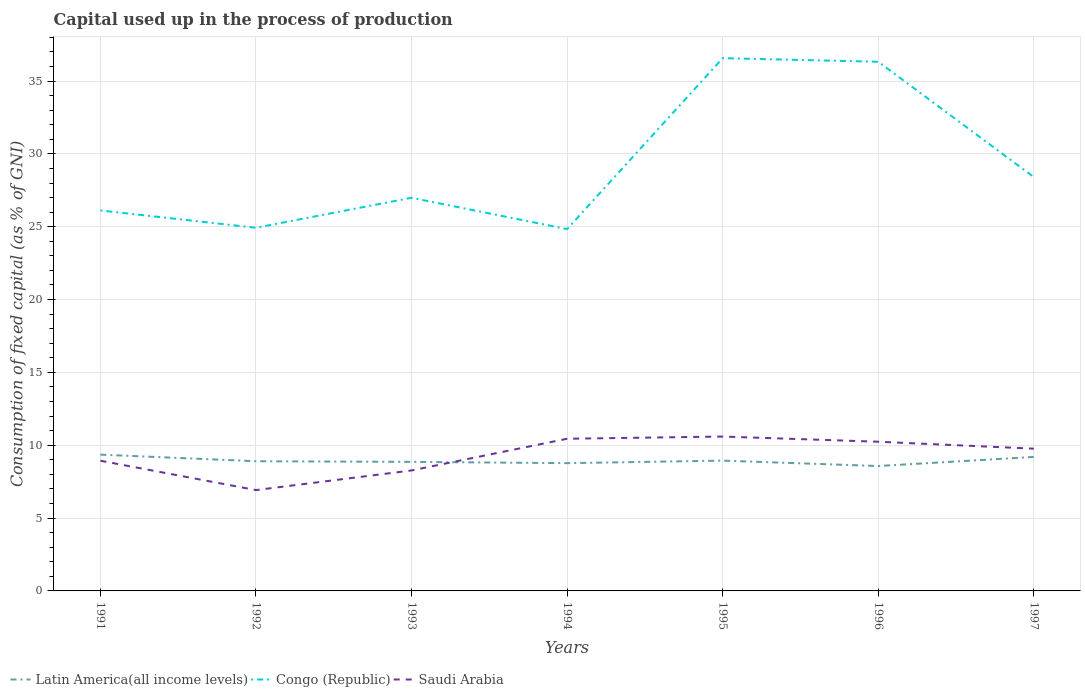Across all years, what is the maximum capital used up in the process of production in Saudi Arabia?
Your response must be concise. 6.92. In which year was the capital used up in the process of production in Congo (Republic) maximum?
Give a very brief answer. 1994. What is the total capital used up in the process of production in Congo (Republic) in the graph?
Your answer should be very brief. -10.45. What is the difference between the highest and the second highest capital used up in the process of production in Congo (Republic)?
Give a very brief answer. 11.73. What is the difference between the highest and the lowest capital used up in the process of production in Latin America(all income levels)?
Give a very brief answer. 3. Is the capital used up in the process of production in Congo (Republic) strictly greater than the capital used up in the process of production in Saudi Arabia over the years?
Keep it short and to the point. No. How many lines are there?
Provide a short and direct response. 3. How many years are there in the graph?
Provide a succinct answer. 7. Are the values on the major ticks of Y-axis written in scientific E-notation?
Provide a succinct answer. No. Does the graph contain grids?
Provide a succinct answer. Yes. Where does the legend appear in the graph?
Provide a succinct answer. Bottom left. How many legend labels are there?
Make the answer very short. 3. What is the title of the graph?
Your answer should be compact. Capital used up in the process of production. Does "Cyprus" appear as one of the legend labels in the graph?
Make the answer very short. No. What is the label or title of the X-axis?
Ensure brevity in your answer.  Years. What is the label or title of the Y-axis?
Offer a terse response. Consumption of fixed capital (as % of GNI). What is the Consumption of fixed capital (as % of GNI) in Latin America(all income levels) in 1991?
Provide a short and direct response. 9.36. What is the Consumption of fixed capital (as % of GNI) of Congo (Republic) in 1991?
Offer a terse response. 26.12. What is the Consumption of fixed capital (as % of GNI) of Saudi Arabia in 1991?
Your response must be concise. 8.94. What is the Consumption of fixed capital (as % of GNI) of Latin America(all income levels) in 1992?
Provide a succinct answer. 8.9. What is the Consumption of fixed capital (as % of GNI) in Congo (Republic) in 1992?
Keep it short and to the point. 24.93. What is the Consumption of fixed capital (as % of GNI) of Saudi Arabia in 1992?
Keep it short and to the point. 6.92. What is the Consumption of fixed capital (as % of GNI) of Latin America(all income levels) in 1993?
Provide a succinct answer. 8.86. What is the Consumption of fixed capital (as % of GNI) in Congo (Republic) in 1993?
Provide a short and direct response. 26.99. What is the Consumption of fixed capital (as % of GNI) of Saudi Arabia in 1993?
Provide a succinct answer. 8.27. What is the Consumption of fixed capital (as % of GNI) of Latin America(all income levels) in 1994?
Offer a terse response. 8.77. What is the Consumption of fixed capital (as % of GNI) of Congo (Republic) in 1994?
Provide a succinct answer. 24.84. What is the Consumption of fixed capital (as % of GNI) in Saudi Arabia in 1994?
Make the answer very short. 10.45. What is the Consumption of fixed capital (as % of GNI) in Latin America(all income levels) in 1995?
Keep it short and to the point. 8.94. What is the Consumption of fixed capital (as % of GNI) of Congo (Republic) in 1995?
Your answer should be very brief. 36.57. What is the Consumption of fixed capital (as % of GNI) in Saudi Arabia in 1995?
Make the answer very short. 10.6. What is the Consumption of fixed capital (as % of GNI) of Latin America(all income levels) in 1996?
Your answer should be compact. 8.57. What is the Consumption of fixed capital (as % of GNI) in Congo (Republic) in 1996?
Ensure brevity in your answer.  36.32. What is the Consumption of fixed capital (as % of GNI) of Saudi Arabia in 1996?
Provide a succinct answer. 10.24. What is the Consumption of fixed capital (as % of GNI) of Latin America(all income levels) in 1997?
Offer a very short reply. 9.2. What is the Consumption of fixed capital (as % of GNI) of Congo (Republic) in 1997?
Ensure brevity in your answer.  28.41. What is the Consumption of fixed capital (as % of GNI) in Saudi Arabia in 1997?
Provide a short and direct response. 9.76. Across all years, what is the maximum Consumption of fixed capital (as % of GNI) of Latin America(all income levels)?
Your answer should be very brief. 9.36. Across all years, what is the maximum Consumption of fixed capital (as % of GNI) in Congo (Republic)?
Give a very brief answer. 36.57. Across all years, what is the maximum Consumption of fixed capital (as % of GNI) in Saudi Arabia?
Provide a short and direct response. 10.6. Across all years, what is the minimum Consumption of fixed capital (as % of GNI) in Latin America(all income levels)?
Your answer should be very brief. 8.57. Across all years, what is the minimum Consumption of fixed capital (as % of GNI) in Congo (Republic)?
Offer a terse response. 24.84. Across all years, what is the minimum Consumption of fixed capital (as % of GNI) of Saudi Arabia?
Your answer should be very brief. 6.92. What is the total Consumption of fixed capital (as % of GNI) in Latin America(all income levels) in the graph?
Your answer should be very brief. 62.6. What is the total Consumption of fixed capital (as % of GNI) in Congo (Republic) in the graph?
Provide a succinct answer. 204.17. What is the total Consumption of fixed capital (as % of GNI) in Saudi Arabia in the graph?
Ensure brevity in your answer.  65.18. What is the difference between the Consumption of fixed capital (as % of GNI) in Latin America(all income levels) in 1991 and that in 1992?
Offer a terse response. 0.45. What is the difference between the Consumption of fixed capital (as % of GNI) of Congo (Republic) in 1991 and that in 1992?
Offer a terse response. 1.19. What is the difference between the Consumption of fixed capital (as % of GNI) of Saudi Arabia in 1991 and that in 1992?
Offer a very short reply. 2.01. What is the difference between the Consumption of fixed capital (as % of GNI) in Latin America(all income levels) in 1991 and that in 1993?
Offer a very short reply. 0.5. What is the difference between the Consumption of fixed capital (as % of GNI) in Congo (Republic) in 1991 and that in 1993?
Your response must be concise. -0.87. What is the difference between the Consumption of fixed capital (as % of GNI) in Saudi Arabia in 1991 and that in 1993?
Give a very brief answer. 0.67. What is the difference between the Consumption of fixed capital (as % of GNI) of Latin America(all income levels) in 1991 and that in 1994?
Provide a short and direct response. 0.58. What is the difference between the Consumption of fixed capital (as % of GNI) of Congo (Republic) in 1991 and that in 1994?
Provide a succinct answer. 1.28. What is the difference between the Consumption of fixed capital (as % of GNI) in Saudi Arabia in 1991 and that in 1994?
Provide a short and direct response. -1.51. What is the difference between the Consumption of fixed capital (as % of GNI) in Latin America(all income levels) in 1991 and that in 1995?
Keep it short and to the point. 0.41. What is the difference between the Consumption of fixed capital (as % of GNI) in Congo (Republic) in 1991 and that in 1995?
Keep it short and to the point. -10.45. What is the difference between the Consumption of fixed capital (as % of GNI) in Saudi Arabia in 1991 and that in 1995?
Your answer should be very brief. -1.66. What is the difference between the Consumption of fixed capital (as % of GNI) of Latin America(all income levels) in 1991 and that in 1996?
Ensure brevity in your answer.  0.78. What is the difference between the Consumption of fixed capital (as % of GNI) of Congo (Republic) in 1991 and that in 1996?
Your response must be concise. -10.2. What is the difference between the Consumption of fixed capital (as % of GNI) in Saudi Arabia in 1991 and that in 1996?
Provide a succinct answer. -1.31. What is the difference between the Consumption of fixed capital (as % of GNI) in Latin America(all income levels) in 1991 and that in 1997?
Ensure brevity in your answer.  0.16. What is the difference between the Consumption of fixed capital (as % of GNI) in Congo (Republic) in 1991 and that in 1997?
Offer a very short reply. -2.29. What is the difference between the Consumption of fixed capital (as % of GNI) in Saudi Arabia in 1991 and that in 1997?
Provide a short and direct response. -0.83. What is the difference between the Consumption of fixed capital (as % of GNI) of Latin America(all income levels) in 1992 and that in 1993?
Offer a terse response. 0.04. What is the difference between the Consumption of fixed capital (as % of GNI) of Congo (Republic) in 1992 and that in 1993?
Your response must be concise. -2.06. What is the difference between the Consumption of fixed capital (as % of GNI) in Saudi Arabia in 1992 and that in 1993?
Offer a very short reply. -1.35. What is the difference between the Consumption of fixed capital (as % of GNI) of Latin America(all income levels) in 1992 and that in 1994?
Provide a succinct answer. 0.13. What is the difference between the Consumption of fixed capital (as % of GNI) in Congo (Republic) in 1992 and that in 1994?
Your answer should be very brief. 0.09. What is the difference between the Consumption of fixed capital (as % of GNI) of Saudi Arabia in 1992 and that in 1994?
Keep it short and to the point. -3.52. What is the difference between the Consumption of fixed capital (as % of GNI) of Latin America(all income levels) in 1992 and that in 1995?
Your answer should be compact. -0.04. What is the difference between the Consumption of fixed capital (as % of GNI) of Congo (Republic) in 1992 and that in 1995?
Keep it short and to the point. -11.64. What is the difference between the Consumption of fixed capital (as % of GNI) in Saudi Arabia in 1992 and that in 1995?
Provide a short and direct response. -3.67. What is the difference between the Consumption of fixed capital (as % of GNI) in Latin America(all income levels) in 1992 and that in 1996?
Give a very brief answer. 0.33. What is the difference between the Consumption of fixed capital (as % of GNI) in Congo (Republic) in 1992 and that in 1996?
Give a very brief answer. -11.39. What is the difference between the Consumption of fixed capital (as % of GNI) of Saudi Arabia in 1992 and that in 1996?
Your answer should be compact. -3.32. What is the difference between the Consumption of fixed capital (as % of GNI) of Latin America(all income levels) in 1992 and that in 1997?
Give a very brief answer. -0.3. What is the difference between the Consumption of fixed capital (as % of GNI) in Congo (Republic) in 1992 and that in 1997?
Make the answer very short. -3.48. What is the difference between the Consumption of fixed capital (as % of GNI) in Saudi Arabia in 1992 and that in 1997?
Offer a terse response. -2.84. What is the difference between the Consumption of fixed capital (as % of GNI) of Latin America(all income levels) in 1993 and that in 1994?
Your answer should be compact. 0.09. What is the difference between the Consumption of fixed capital (as % of GNI) of Congo (Republic) in 1993 and that in 1994?
Offer a very short reply. 2.15. What is the difference between the Consumption of fixed capital (as % of GNI) in Saudi Arabia in 1993 and that in 1994?
Give a very brief answer. -2.18. What is the difference between the Consumption of fixed capital (as % of GNI) in Latin America(all income levels) in 1993 and that in 1995?
Offer a very short reply. -0.09. What is the difference between the Consumption of fixed capital (as % of GNI) of Congo (Republic) in 1993 and that in 1995?
Ensure brevity in your answer.  -9.58. What is the difference between the Consumption of fixed capital (as % of GNI) in Saudi Arabia in 1993 and that in 1995?
Your answer should be very brief. -2.33. What is the difference between the Consumption of fixed capital (as % of GNI) of Latin America(all income levels) in 1993 and that in 1996?
Make the answer very short. 0.29. What is the difference between the Consumption of fixed capital (as % of GNI) in Congo (Republic) in 1993 and that in 1996?
Offer a terse response. -9.34. What is the difference between the Consumption of fixed capital (as % of GNI) in Saudi Arabia in 1993 and that in 1996?
Offer a terse response. -1.97. What is the difference between the Consumption of fixed capital (as % of GNI) of Latin America(all income levels) in 1993 and that in 1997?
Keep it short and to the point. -0.34. What is the difference between the Consumption of fixed capital (as % of GNI) of Congo (Republic) in 1993 and that in 1997?
Give a very brief answer. -1.42. What is the difference between the Consumption of fixed capital (as % of GNI) in Saudi Arabia in 1993 and that in 1997?
Provide a short and direct response. -1.5. What is the difference between the Consumption of fixed capital (as % of GNI) in Latin America(all income levels) in 1994 and that in 1995?
Provide a short and direct response. -0.17. What is the difference between the Consumption of fixed capital (as % of GNI) in Congo (Republic) in 1994 and that in 1995?
Make the answer very short. -11.73. What is the difference between the Consumption of fixed capital (as % of GNI) in Saudi Arabia in 1994 and that in 1995?
Provide a short and direct response. -0.15. What is the difference between the Consumption of fixed capital (as % of GNI) of Latin America(all income levels) in 1994 and that in 1996?
Your answer should be very brief. 0.2. What is the difference between the Consumption of fixed capital (as % of GNI) of Congo (Republic) in 1994 and that in 1996?
Keep it short and to the point. -11.49. What is the difference between the Consumption of fixed capital (as % of GNI) of Saudi Arabia in 1994 and that in 1996?
Keep it short and to the point. 0.2. What is the difference between the Consumption of fixed capital (as % of GNI) of Latin America(all income levels) in 1994 and that in 1997?
Provide a succinct answer. -0.43. What is the difference between the Consumption of fixed capital (as % of GNI) in Congo (Republic) in 1994 and that in 1997?
Provide a succinct answer. -3.57. What is the difference between the Consumption of fixed capital (as % of GNI) of Saudi Arabia in 1994 and that in 1997?
Your answer should be very brief. 0.68. What is the difference between the Consumption of fixed capital (as % of GNI) of Latin America(all income levels) in 1995 and that in 1996?
Provide a short and direct response. 0.37. What is the difference between the Consumption of fixed capital (as % of GNI) of Congo (Republic) in 1995 and that in 1996?
Keep it short and to the point. 0.25. What is the difference between the Consumption of fixed capital (as % of GNI) of Saudi Arabia in 1995 and that in 1996?
Give a very brief answer. 0.36. What is the difference between the Consumption of fixed capital (as % of GNI) of Latin America(all income levels) in 1995 and that in 1997?
Make the answer very short. -0.25. What is the difference between the Consumption of fixed capital (as % of GNI) in Congo (Republic) in 1995 and that in 1997?
Your response must be concise. 8.16. What is the difference between the Consumption of fixed capital (as % of GNI) of Saudi Arabia in 1995 and that in 1997?
Make the answer very short. 0.83. What is the difference between the Consumption of fixed capital (as % of GNI) in Latin America(all income levels) in 1996 and that in 1997?
Provide a succinct answer. -0.63. What is the difference between the Consumption of fixed capital (as % of GNI) in Congo (Republic) in 1996 and that in 1997?
Provide a succinct answer. 7.91. What is the difference between the Consumption of fixed capital (as % of GNI) in Saudi Arabia in 1996 and that in 1997?
Keep it short and to the point. 0.48. What is the difference between the Consumption of fixed capital (as % of GNI) of Latin America(all income levels) in 1991 and the Consumption of fixed capital (as % of GNI) of Congo (Republic) in 1992?
Provide a short and direct response. -15.57. What is the difference between the Consumption of fixed capital (as % of GNI) in Latin America(all income levels) in 1991 and the Consumption of fixed capital (as % of GNI) in Saudi Arabia in 1992?
Make the answer very short. 2.43. What is the difference between the Consumption of fixed capital (as % of GNI) in Congo (Republic) in 1991 and the Consumption of fixed capital (as % of GNI) in Saudi Arabia in 1992?
Make the answer very short. 19.2. What is the difference between the Consumption of fixed capital (as % of GNI) of Latin America(all income levels) in 1991 and the Consumption of fixed capital (as % of GNI) of Congo (Republic) in 1993?
Make the answer very short. -17.63. What is the difference between the Consumption of fixed capital (as % of GNI) of Latin America(all income levels) in 1991 and the Consumption of fixed capital (as % of GNI) of Saudi Arabia in 1993?
Your answer should be very brief. 1.09. What is the difference between the Consumption of fixed capital (as % of GNI) of Congo (Republic) in 1991 and the Consumption of fixed capital (as % of GNI) of Saudi Arabia in 1993?
Offer a very short reply. 17.85. What is the difference between the Consumption of fixed capital (as % of GNI) in Latin America(all income levels) in 1991 and the Consumption of fixed capital (as % of GNI) in Congo (Republic) in 1994?
Keep it short and to the point. -15.48. What is the difference between the Consumption of fixed capital (as % of GNI) in Latin America(all income levels) in 1991 and the Consumption of fixed capital (as % of GNI) in Saudi Arabia in 1994?
Your answer should be compact. -1.09. What is the difference between the Consumption of fixed capital (as % of GNI) in Congo (Republic) in 1991 and the Consumption of fixed capital (as % of GNI) in Saudi Arabia in 1994?
Your response must be concise. 15.67. What is the difference between the Consumption of fixed capital (as % of GNI) of Latin America(all income levels) in 1991 and the Consumption of fixed capital (as % of GNI) of Congo (Republic) in 1995?
Provide a succinct answer. -27.21. What is the difference between the Consumption of fixed capital (as % of GNI) of Latin America(all income levels) in 1991 and the Consumption of fixed capital (as % of GNI) of Saudi Arabia in 1995?
Keep it short and to the point. -1.24. What is the difference between the Consumption of fixed capital (as % of GNI) of Congo (Republic) in 1991 and the Consumption of fixed capital (as % of GNI) of Saudi Arabia in 1995?
Offer a terse response. 15.52. What is the difference between the Consumption of fixed capital (as % of GNI) of Latin America(all income levels) in 1991 and the Consumption of fixed capital (as % of GNI) of Congo (Republic) in 1996?
Your answer should be very brief. -26.97. What is the difference between the Consumption of fixed capital (as % of GNI) in Latin America(all income levels) in 1991 and the Consumption of fixed capital (as % of GNI) in Saudi Arabia in 1996?
Keep it short and to the point. -0.89. What is the difference between the Consumption of fixed capital (as % of GNI) in Congo (Republic) in 1991 and the Consumption of fixed capital (as % of GNI) in Saudi Arabia in 1996?
Your answer should be very brief. 15.88. What is the difference between the Consumption of fixed capital (as % of GNI) of Latin America(all income levels) in 1991 and the Consumption of fixed capital (as % of GNI) of Congo (Republic) in 1997?
Your answer should be very brief. -19.05. What is the difference between the Consumption of fixed capital (as % of GNI) in Latin America(all income levels) in 1991 and the Consumption of fixed capital (as % of GNI) in Saudi Arabia in 1997?
Your response must be concise. -0.41. What is the difference between the Consumption of fixed capital (as % of GNI) of Congo (Republic) in 1991 and the Consumption of fixed capital (as % of GNI) of Saudi Arabia in 1997?
Give a very brief answer. 16.35. What is the difference between the Consumption of fixed capital (as % of GNI) in Latin America(all income levels) in 1992 and the Consumption of fixed capital (as % of GNI) in Congo (Republic) in 1993?
Your answer should be compact. -18.08. What is the difference between the Consumption of fixed capital (as % of GNI) in Latin America(all income levels) in 1992 and the Consumption of fixed capital (as % of GNI) in Saudi Arabia in 1993?
Provide a short and direct response. 0.63. What is the difference between the Consumption of fixed capital (as % of GNI) of Congo (Republic) in 1992 and the Consumption of fixed capital (as % of GNI) of Saudi Arabia in 1993?
Your answer should be compact. 16.66. What is the difference between the Consumption of fixed capital (as % of GNI) in Latin America(all income levels) in 1992 and the Consumption of fixed capital (as % of GNI) in Congo (Republic) in 1994?
Your response must be concise. -15.94. What is the difference between the Consumption of fixed capital (as % of GNI) of Latin America(all income levels) in 1992 and the Consumption of fixed capital (as % of GNI) of Saudi Arabia in 1994?
Your answer should be very brief. -1.54. What is the difference between the Consumption of fixed capital (as % of GNI) of Congo (Republic) in 1992 and the Consumption of fixed capital (as % of GNI) of Saudi Arabia in 1994?
Your answer should be very brief. 14.48. What is the difference between the Consumption of fixed capital (as % of GNI) in Latin America(all income levels) in 1992 and the Consumption of fixed capital (as % of GNI) in Congo (Republic) in 1995?
Your answer should be compact. -27.67. What is the difference between the Consumption of fixed capital (as % of GNI) in Latin America(all income levels) in 1992 and the Consumption of fixed capital (as % of GNI) in Saudi Arabia in 1995?
Make the answer very short. -1.7. What is the difference between the Consumption of fixed capital (as % of GNI) of Congo (Republic) in 1992 and the Consumption of fixed capital (as % of GNI) of Saudi Arabia in 1995?
Offer a very short reply. 14.33. What is the difference between the Consumption of fixed capital (as % of GNI) of Latin America(all income levels) in 1992 and the Consumption of fixed capital (as % of GNI) of Congo (Republic) in 1996?
Offer a very short reply. -27.42. What is the difference between the Consumption of fixed capital (as % of GNI) in Latin America(all income levels) in 1992 and the Consumption of fixed capital (as % of GNI) in Saudi Arabia in 1996?
Provide a short and direct response. -1.34. What is the difference between the Consumption of fixed capital (as % of GNI) in Congo (Republic) in 1992 and the Consumption of fixed capital (as % of GNI) in Saudi Arabia in 1996?
Give a very brief answer. 14.69. What is the difference between the Consumption of fixed capital (as % of GNI) of Latin America(all income levels) in 1992 and the Consumption of fixed capital (as % of GNI) of Congo (Republic) in 1997?
Ensure brevity in your answer.  -19.51. What is the difference between the Consumption of fixed capital (as % of GNI) in Latin America(all income levels) in 1992 and the Consumption of fixed capital (as % of GNI) in Saudi Arabia in 1997?
Offer a terse response. -0.86. What is the difference between the Consumption of fixed capital (as % of GNI) in Congo (Republic) in 1992 and the Consumption of fixed capital (as % of GNI) in Saudi Arabia in 1997?
Offer a terse response. 15.16. What is the difference between the Consumption of fixed capital (as % of GNI) of Latin America(all income levels) in 1993 and the Consumption of fixed capital (as % of GNI) of Congo (Republic) in 1994?
Ensure brevity in your answer.  -15.98. What is the difference between the Consumption of fixed capital (as % of GNI) of Latin America(all income levels) in 1993 and the Consumption of fixed capital (as % of GNI) of Saudi Arabia in 1994?
Provide a short and direct response. -1.59. What is the difference between the Consumption of fixed capital (as % of GNI) in Congo (Republic) in 1993 and the Consumption of fixed capital (as % of GNI) in Saudi Arabia in 1994?
Make the answer very short. 16.54. What is the difference between the Consumption of fixed capital (as % of GNI) of Latin America(all income levels) in 1993 and the Consumption of fixed capital (as % of GNI) of Congo (Republic) in 1995?
Your answer should be compact. -27.71. What is the difference between the Consumption of fixed capital (as % of GNI) of Latin America(all income levels) in 1993 and the Consumption of fixed capital (as % of GNI) of Saudi Arabia in 1995?
Keep it short and to the point. -1.74. What is the difference between the Consumption of fixed capital (as % of GNI) in Congo (Republic) in 1993 and the Consumption of fixed capital (as % of GNI) in Saudi Arabia in 1995?
Give a very brief answer. 16.39. What is the difference between the Consumption of fixed capital (as % of GNI) in Latin America(all income levels) in 1993 and the Consumption of fixed capital (as % of GNI) in Congo (Republic) in 1996?
Offer a very short reply. -27.46. What is the difference between the Consumption of fixed capital (as % of GNI) of Latin America(all income levels) in 1993 and the Consumption of fixed capital (as % of GNI) of Saudi Arabia in 1996?
Keep it short and to the point. -1.38. What is the difference between the Consumption of fixed capital (as % of GNI) in Congo (Republic) in 1993 and the Consumption of fixed capital (as % of GNI) in Saudi Arabia in 1996?
Offer a very short reply. 16.74. What is the difference between the Consumption of fixed capital (as % of GNI) in Latin America(all income levels) in 1993 and the Consumption of fixed capital (as % of GNI) in Congo (Republic) in 1997?
Offer a terse response. -19.55. What is the difference between the Consumption of fixed capital (as % of GNI) in Latin America(all income levels) in 1993 and the Consumption of fixed capital (as % of GNI) in Saudi Arabia in 1997?
Provide a short and direct response. -0.91. What is the difference between the Consumption of fixed capital (as % of GNI) of Congo (Republic) in 1993 and the Consumption of fixed capital (as % of GNI) of Saudi Arabia in 1997?
Offer a terse response. 17.22. What is the difference between the Consumption of fixed capital (as % of GNI) of Latin America(all income levels) in 1994 and the Consumption of fixed capital (as % of GNI) of Congo (Republic) in 1995?
Offer a terse response. -27.8. What is the difference between the Consumption of fixed capital (as % of GNI) in Latin America(all income levels) in 1994 and the Consumption of fixed capital (as % of GNI) in Saudi Arabia in 1995?
Your response must be concise. -1.83. What is the difference between the Consumption of fixed capital (as % of GNI) in Congo (Republic) in 1994 and the Consumption of fixed capital (as % of GNI) in Saudi Arabia in 1995?
Offer a very short reply. 14.24. What is the difference between the Consumption of fixed capital (as % of GNI) of Latin America(all income levels) in 1994 and the Consumption of fixed capital (as % of GNI) of Congo (Republic) in 1996?
Keep it short and to the point. -27.55. What is the difference between the Consumption of fixed capital (as % of GNI) in Latin America(all income levels) in 1994 and the Consumption of fixed capital (as % of GNI) in Saudi Arabia in 1996?
Give a very brief answer. -1.47. What is the difference between the Consumption of fixed capital (as % of GNI) of Congo (Republic) in 1994 and the Consumption of fixed capital (as % of GNI) of Saudi Arabia in 1996?
Ensure brevity in your answer.  14.6. What is the difference between the Consumption of fixed capital (as % of GNI) of Latin America(all income levels) in 1994 and the Consumption of fixed capital (as % of GNI) of Congo (Republic) in 1997?
Make the answer very short. -19.64. What is the difference between the Consumption of fixed capital (as % of GNI) in Latin America(all income levels) in 1994 and the Consumption of fixed capital (as % of GNI) in Saudi Arabia in 1997?
Provide a succinct answer. -0.99. What is the difference between the Consumption of fixed capital (as % of GNI) in Congo (Republic) in 1994 and the Consumption of fixed capital (as % of GNI) in Saudi Arabia in 1997?
Provide a short and direct response. 15.07. What is the difference between the Consumption of fixed capital (as % of GNI) in Latin America(all income levels) in 1995 and the Consumption of fixed capital (as % of GNI) in Congo (Republic) in 1996?
Your answer should be compact. -27.38. What is the difference between the Consumption of fixed capital (as % of GNI) in Latin America(all income levels) in 1995 and the Consumption of fixed capital (as % of GNI) in Saudi Arabia in 1996?
Your answer should be compact. -1.3. What is the difference between the Consumption of fixed capital (as % of GNI) in Congo (Republic) in 1995 and the Consumption of fixed capital (as % of GNI) in Saudi Arabia in 1996?
Make the answer very short. 26.33. What is the difference between the Consumption of fixed capital (as % of GNI) of Latin America(all income levels) in 1995 and the Consumption of fixed capital (as % of GNI) of Congo (Republic) in 1997?
Make the answer very short. -19.46. What is the difference between the Consumption of fixed capital (as % of GNI) of Latin America(all income levels) in 1995 and the Consumption of fixed capital (as % of GNI) of Saudi Arabia in 1997?
Make the answer very short. -0.82. What is the difference between the Consumption of fixed capital (as % of GNI) of Congo (Republic) in 1995 and the Consumption of fixed capital (as % of GNI) of Saudi Arabia in 1997?
Offer a terse response. 26.8. What is the difference between the Consumption of fixed capital (as % of GNI) of Latin America(all income levels) in 1996 and the Consumption of fixed capital (as % of GNI) of Congo (Republic) in 1997?
Provide a succinct answer. -19.84. What is the difference between the Consumption of fixed capital (as % of GNI) of Latin America(all income levels) in 1996 and the Consumption of fixed capital (as % of GNI) of Saudi Arabia in 1997?
Your response must be concise. -1.19. What is the difference between the Consumption of fixed capital (as % of GNI) in Congo (Republic) in 1996 and the Consumption of fixed capital (as % of GNI) in Saudi Arabia in 1997?
Give a very brief answer. 26.56. What is the average Consumption of fixed capital (as % of GNI) in Latin America(all income levels) per year?
Provide a succinct answer. 8.94. What is the average Consumption of fixed capital (as % of GNI) in Congo (Republic) per year?
Offer a very short reply. 29.17. What is the average Consumption of fixed capital (as % of GNI) of Saudi Arabia per year?
Offer a very short reply. 9.31. In the year 1991, what is the difference between the Consumption of fixed capital (as % of GNI) of Latin America(all income levels) and Consumption of fixed capital (as % of GNI) of Congo (Republic)?
Offer a very short reply. -16.76. In the year 1991, what is the difference between the Consumption of fixed capital (as % of GNI) of Latin America(all income levels) and Consumption of fixed capital (as % of GNI) of Saudi Arabia?
Make the answer very short. 0.42. In the year 1991, what is the difference between the Consumption of fixed capital (as % of GNI) of Congo (Republic) and Consumption of fixed capital (as % of GNI) of Saudi Arabia?
Your response must be concise. 17.18. In the year 1992, what is the difference between the Consumption of fixed capital (as % of GNI) in Latin America(all income levels) and Consumption of fixed capital (as % of GNI) in Congo (Republic)?
Make the answer very short. -16.03. In the year 1992, what is the difference between the Consumption of fixed capital (as % of GNI) in Latin America(all income levels) and Consumption of fixed capital (as % of GNI) in Saudi Arabia?
Provide a short and direct response. 1.98. In the year 1992, what is the difference between the Consumption of fixed capital (as % of GNI) of Congo (Republic) and Consumption of fixed capital (as % of GNI) of Saudi Arabia?
Keep it short and to the point. 18.01. In the year 1993, what is the difference between the Consumption of fixed capital (as % of GNI) in Latin America(all income levels) and Consumption of fixed capital (as % of GNI) in Congo (Republic)?
Your answer should be compact. -18.13. In the year 1993, what is the difference between the Consumption of fixed capital (as % of GNI) of Latin America(all income levels) and Consumption of fixed capital (as % of GNI) of Saudi Arabia?
Offer a very short reply. 0.59. In the year 1993, what is the difference between the Consumption of fixed capital (as % of GNI) of Congo (Republic) and Consumption of fixed capital (as % of GNI) of Saudi Arabia?
Your answer should be compact. 18.72. In the year 1994, what is the difference between the Consumption of fixed capital (as % of GNI) in Latin America(all income levels) and Consumption of fixed capital (as % of GNI) in Congo (Republic)?
Offer a very short reply. -16.07. In the year 1994, what is the difference between the Consumption of fixed capital (as % of GNI) of Latin America(all income levels) and Consumption of fixed capital (as % of GNI) of Saudi Arabia?
Ensure brevity in your answer.  -1.68. In the year 1994, what is the difference between the Consumption of fixed capital (as % of GNI) in Congo (Republic) and Consumption of fixed capital (as % of GNI) in Saudi Arabia?
Offer a terse response. 14.39. In the year 1995, what is the difference between the Consumption of fixed capital (as % of GNI) in Latin America(all income levels) and Consumption of fixed capital (as % of GNI) in Congo (Republic)?
Your response must be concise. -27.63. In the year 1995, what is the difference between the Consumption of fixed capital (as % of GNI) of Latin America(all income levels) and Consumption of fixed capital (as % of GNI) of Saudi Arabia?
Provide a succinct answer. -1.65. In the year 1995, what is the difference between the Consumption of fixed capital (as % of GNI) of Congo (Republic) and Consumption of fixed capital (as % of GNI) of Saudi Arabia?
Your response must be concise. 25.97. In the year 1996, what is the difference between the Consumption of fixed capital (as % of GNI) of Latin America(all income levels) and Consumption of fixed capital (as % of GNI) of Congo (Republic)?
Offer a terse response. -27.75. In the year 1996, what is the difference between the Consumption of fixed capital (as % of GNI) in Latin America(all income levels) and Consumption of fixed capital (as % of GNI) in Saudi Arabia?
Make the answer very short. -1.67. In the year 1996, what is the difference between the Consumption of fixed capital (as % of GNI) in Congo (Republic) and Consumption of fixed capital (as % of GNI) in Saudi Arabia?
Your answer should be very brief. 26.08. In the year 1997, what is the difference between the Consumption of fixed capital (as % of GNI) of Latin America(all income levels) and Consumption of fixed capital (as % of GNI) of Congo (Republic)?
Offer a terse response. -19.21. In the year 1997, what is the difference between the Consumption of fixed capital (as % of GNI) of Latin America(all income levels) and Consumption of fixed capital (as % of GNI) of Saudi Arabia?
Ensure brevity in your answer.  -0.57. In the year 1997, what is the difference between the Consumption of fixed capital (as % of GNI) in Congo (Republic) and Consumption of fixed capital (as % of GNI) in Saudi Arabia?
Ensure brevity in your answer.  18.64. What is the ratio of the Consumption of fixed capital (as % of GNI) in Latin America(all income levels) in 1991 to that in 1992?
Offer a very short reply. 1.05. What is the ratio of the Consumption of fixed capital (as % of GNI) of Congo (Republic) in 1991 to that in 1992?
Offer a very short reply. 1.05. What is the ratio of the Consumption of fixed capital (as % of GNI) in Saudi Arabia in 1991 to that in 1992?
Keep it short and to the point. 1.29. What is the ratio of the Consumption of fixed capital (as % of GNI) of Latin America(all income levels) in 1991 to that in 1993?
Provide a succinct answer. 1.06. What is the ratio of the Consumption of fixed capital (as % of GNI) in Congo (Republic) in 1991 to that in 1993?
Offer a very short reply. 0.97. What is the ratio of the Consumption of fixed capital (as % of GNI) of Saudi Arabia in 1991 to that in 1993?
Your answer should be very brief. 1.08. What is the ratio of the Consumption of fixed capital (as % of GNI) in Latin America(all income levels) in 1991 to that in 1994?
Give a very brief answer. 1.07. What is the ratio of the Consumption of fixed capital (as % of GNI) in Congo (Republic) in 1991 to that in 1994?
Provide a short and direct response. 1.05. What is the ratio of the Consumption of fixed capital (as % of GNI) of Saudi Arabia in 1991 to that in 1994?
Make the answer very short. 0.86. What is the ratio of the Consumption of fixed capital (as % of GNI) of Latin America(all income levels) in 1991 to that in 1995?
Offer a terse response. 1.05. What is the ratio of the Consumption of fixed capital (as % of GNI) of Congo (Republic) in 1991 to that in 1995?
Keep it short and to the point. 0.71. What is the ratio of the Consumption of fixed capital (as % of GNI) of Saudi Arabia in 1991 to that in 1995?
Make the answer very short. 0.84. What is the ratio of the Consumption of fixed capital (as % of GNI) of Latin America(all income levels) in 1991 to that in 1996?
Offer a very short reply. 1.09. What is the ratio of the Consumption of fixed capital (as % of GNI) in Congo (Republic) in 1991 to that in 1996?
Give a very brief answer. 0.72. What is the ratio of the Consumption of fixed capital (as % of GNI) of Saudi Arabia in 1991 to that in 1996?
Provide a short and direct response. 0.87. What is the ratio of the Consumption of fixed capital (as % of GNI) of Latin America(all income levels) in 1991 to that in 1997?
Offer a very short reply. 1.02. What is the ratio of the Consumption of fixed capital (as % of GNI) in Congo (Republic) in 1991 to that in 1997?
Your answer should be compact. 0.92. What is the ratio of the Consumption of fixed capital (as % of GNI) in Saudi Arabia in 1991 to that in 1997?
Give a very brief answer. 0.92. What is the ratio of the Consumption of fixed capital (as % of GNI) of Latin America(all income levels) in 1992 to that in 1993?
Ensure brevity in your answer.  1. What is the ratio of the Consumption of fixed capital (as % of GNI) in Congo (Republic) in 1992 to that in 1993?
Your answer should be compact. 0.92. What is the ratio of the Consumption of fixed capital (as % of GNI) in Saudi Arabia in 1992 to that in 1993?
Make the answer very short. 0.84. What is the ratio of the Consumption of fixed capital (as % of GNI) of Latin America(all income levels) in 1992 to that in 1994?
Your answer should be very brief. 1.01. What is the ratio of the Consumption of fixed capital (as % of GNI) of Saudi Arabia in 1992 to that in 1994?
Ensure brevity in your answer.  0.66. What is the ratio of the Consumption of fixed capital (as % of GNI) of Congo (Republic) in 1992 to that in 1995?
Give a very brief answer. 0.68. What is the ratio of the Consumption of fixed capital (as % of GNI) of Saudi Arabia in 1992 to that in 1995?
Provide a succinct answer. 0.65. What is the ratio of the Consumption of fixed capital (as % of GNI) of Latin America(all income levels) in 1992 to that in 1996?
Your answer should be very brief. 1.04. What is the ratio of the Consumption of fixed capital (as % of GNI) in Congo (Republic) in 1992 to that in 1996?
Offer a terse response. 0.69. What is the ratio of the Consumption of fixed capital (as % of GNI) of Saudi Arabia in 1992 to that in 1996?
Ensure brevity in your answer.  0.68. What is the ratio of the Consumption of fixed capital (as % of GNI) of Latin America(all income levels) in 1992 to that in 1997?
Provide a short and direct response. 0.97. What is the ratio of the Consumption of fixed capital (as % of GNI) in Congo (Republic) in 1992 to that in 1997?
Give a very brief answer. 0.88. What is the ratio of the Consumption of fixed capital (as % of GNI) of Saudi Arabia in 1992 to that in 1997?
Keep it short and to the point. 0.71. What is the ratio of the Consumption of fixed capital (as % of GNI) in Latin America(all income levels) in 1993 to that in 1994?
Keep it short and to the point. 1.01. What is the ratio of the Consumption of fixed capital (as % of GNI) in Congo (Republic) in 1993 to that in 1994?
Provide a short and direct response. 1.09. What is the ratio of the Consumption of fixed capital (as % of GNI) in Saudi Arabia in 1993 to that in 1994?
Your answer should be very brief. 0.79. What is the ratio of the Consumption of fixed capital (as % of GNI) of Latin America(all income levels) in 1993 to that in 1995?
Offer a very short reply. 0.99. What is the ratio of the Consumption of fixed capital (as % of GNI) in Congo (Republic) in 1993 to that in 1995?
Make the answer very short. 0.74. What is the ratio of the Consumption of fixed capital (as % of GNI) in Saudi Arabia in 1993 to that in 1995?
Offer a very short reply. 0.78. What is the ratio of the Consumption of fixed capital (as % of GNI) of Congo (Republic) in 1993 to that in 1996?
Offer a very short reply. 0.74. What is the ratio of the Consumption of fixed capital (as % of GNI) in Saudi Arabia in 1993 to that in 1996?
Give a very brief answer. 0.81. What is the ratio of the Consumption of fixed capital (as % of GNI) of Latin America(all income levels) in 1993 to that in 1997?
Ensure brevity in your answer.  0.96. What is the ratio of the Consumption of fixed capital (as % of GNI) of Congo (Republic) in 1993 to that in 1997?
Make the answer very short. 0.95. What is the ratio of the Consumption of fixed capital (as % of GNI) of Saudi Arabia in 1993 to that in 1997?
Give a very brief answer. 0.85. What is the ratio of the Consumption of fixed capital (as % of GNI) in Latin America(all income levels) in 1994 to that in 1995?
Offer a very short reply. 0.98. What is the ratio of the Consumption of fixed capital (as % of GNI) in Congo (Republic) in 1994 to that in 1995?
Your response must be concise. 0.68. What is the ratio of the Consumption of fixed capital (as % of GNI) in Saudi Arabia in 1994 to that in 1995?
Provide a succinct answer. 0.99. What is the ratio of the Consumption of fixed capital (as % of GNI) in Latin America(all income levels) in 1994 to that in 1996?
Provide a succinct answer. 1.02. What is the ratio of the Consumption of fixed capital (as % of GNI) in Congo (Republic) in 1994 to that in 1996?
Give a very brief answer. 0.68. What is the ratio of the Consumption of fixed capital (as % of GNI) in Saudi Arabia in 1994 to that in 1996?
Give a very brief answer. 1.02. What is the ratio of the Consumption of fixed capital (as % of GNI) of Latin America(all income levels) in 1994 to that in 1997?
Offer a terse response. 0.95. What is the ratio of the Consumption of fixed capital (as % of GNI) of Congo (Republic) in 1994 to that in 1997?
Ensure brevity in your answer.  0.87. What is the ratio of the Consumption of fixed capital (as % of GNI) of Saudi Arabia in 1994 to that in 1997?
Provide a succinct answer. 1.07. What is the ratio of the Consumption of fixed capital (as % of GNI) in Latin America(all income levels) in 1995 to that in 1996?
Offer a very short reply. 1.04. What is the ratio of the Consumption of fixed capital (as % of GNI) of Congo (Republic) in 1995 to that in 1996?
Offer a terse response. 1.01. What is the ratio of the Consumption of fixed capital (as % of GNI) of Saudi Arabia in 1995 to that in 1996?
Offer a terse response. 1.03. What is the ratio of the Consumption of fixed capital (as % of GNI) in Latin America(all income levels) in 1995 to that in 1997?
Ensure brevity in your answer.  0.97. What is the ratio of the Consumption of fixed capital (as % of GNI) of Congo (Republic) in 1995 to that in 1997?
Your answer should be compact. 1.29. What is the ratio of the Consumption of fixed capital (as % of GNI) in Saudi Arabia in 1995 to that in 1997?
Your answer should be compact. 1.09. What is the ratio of the Consumption of fixed capital (as % of GNI) in Latin America(all income levels) in 1996 to that in 1997?
Offer a very short reply. 0.93. What is the ratio of the Consumption of fixed capital (as % of GNI) of Congo (Republic) in 1996 to that in 1997?
Make the answer very short. 1.28. What is the ratio of the Consumption of fixed capital (as % of GNI) of Saudi Arabia in 1996 to that in 1997?
Offer a very short reply. 1.05. What is the difference between the highest and the second highest Consumption of fixed capital (as % of GNI) of Latin America(all income levels)?
Your response must be concise. 0.16. What is the difference between the highest and the second highest Consumption of fixed capital (as % of GNI) of Congo (Republic)?
Your answer should be compact. 0.25. What is the difference between the highest and the second highest Consumption of fixed capital (as % of GNI) in Saudi Arabia?
Ensure brevity in your answer.  0.15. What is the difference between the highest and the lowest Consumption of fixed capital (as % of GNI) of Latin America(all income levels)?
Ensure brevity in your answer.  0.78. What is the difference between the highest and the lowest Consumption of fixed capital (as % of GNI) of Congo (Republic)?
Your answer should be compact. 11.73. What is the difference between the highest and the lowest Consumption of fixed capital (as % of GNI) in Saudi Arabia?
Offer a terse response. 3.67. 